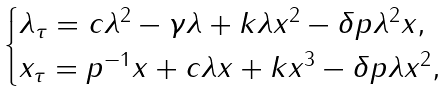Convert formula to latex. <formula><loc_0><loc_0><loc_500><loc_500>\begin{cases} \lambda _ { \tau } = c \lambda ^ { 2 } - \gamma \lambda + k \lambda x ^ { 2 } - \delta p \lambda ^ { 2 } x , \\ x _ { \tau } = p ^ { - 1 } x + c \lambda x + k x ^ { 3 } - \delta p \lambda x ^ { 2 } , \end{cases}</formula> 